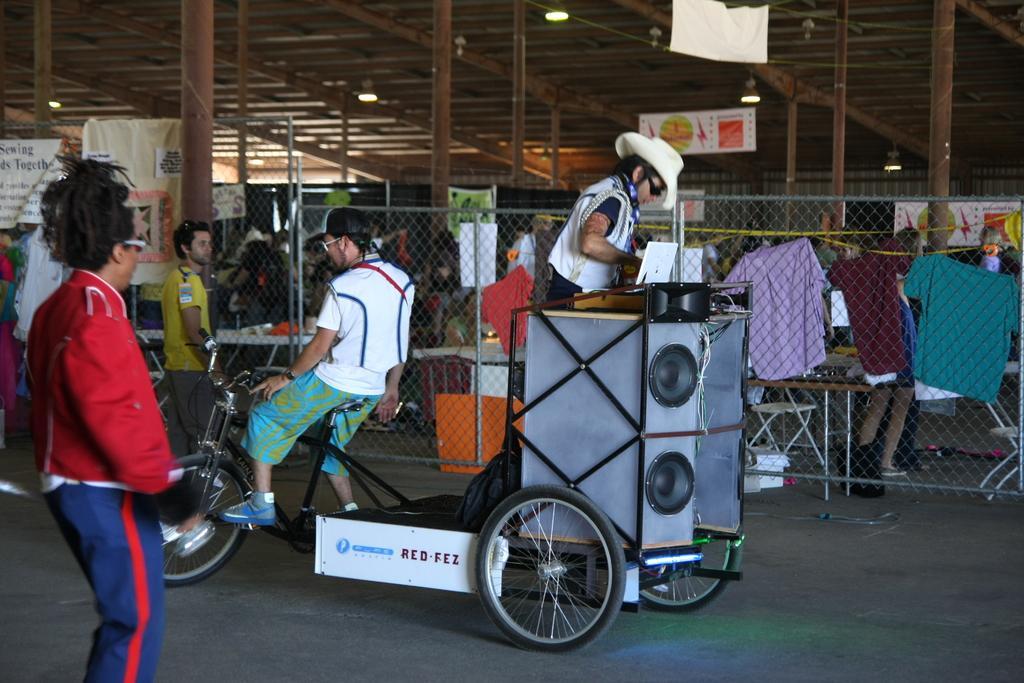In one or two sentences, can you explain what this image depicts? There is a group of people. On the left side person is standing. In the center we have a another person. His sitting on a bicycle. We can see in the background there is a net and shirts and poles. 